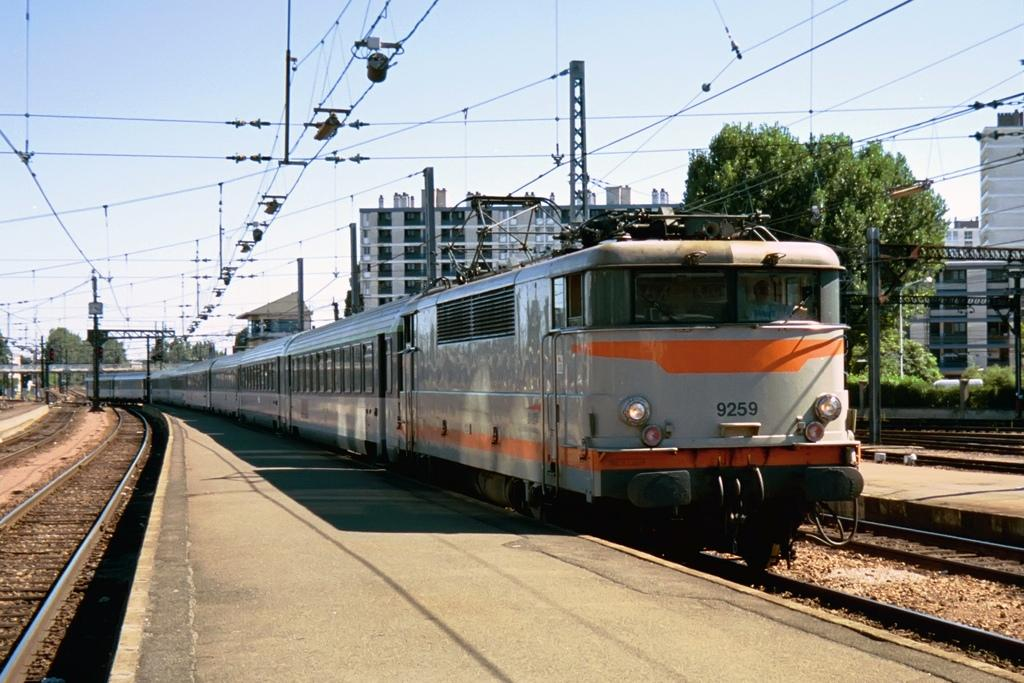What is the main subject of the image? The main subject of the image is a train. What can be seen alongside the train in the image? There is a railway track in the image. What type of vegetation is present in the image? There are plants and trees in the image. What type of man-made structures can be seen in the image? There are buildings in the image. What is visible in the background of the image? The sky is visible in the image. What is the chance of the train whistling in the image? There is no indication of the train whistling in the image, so it's not possible to determine the chance of it happening. 